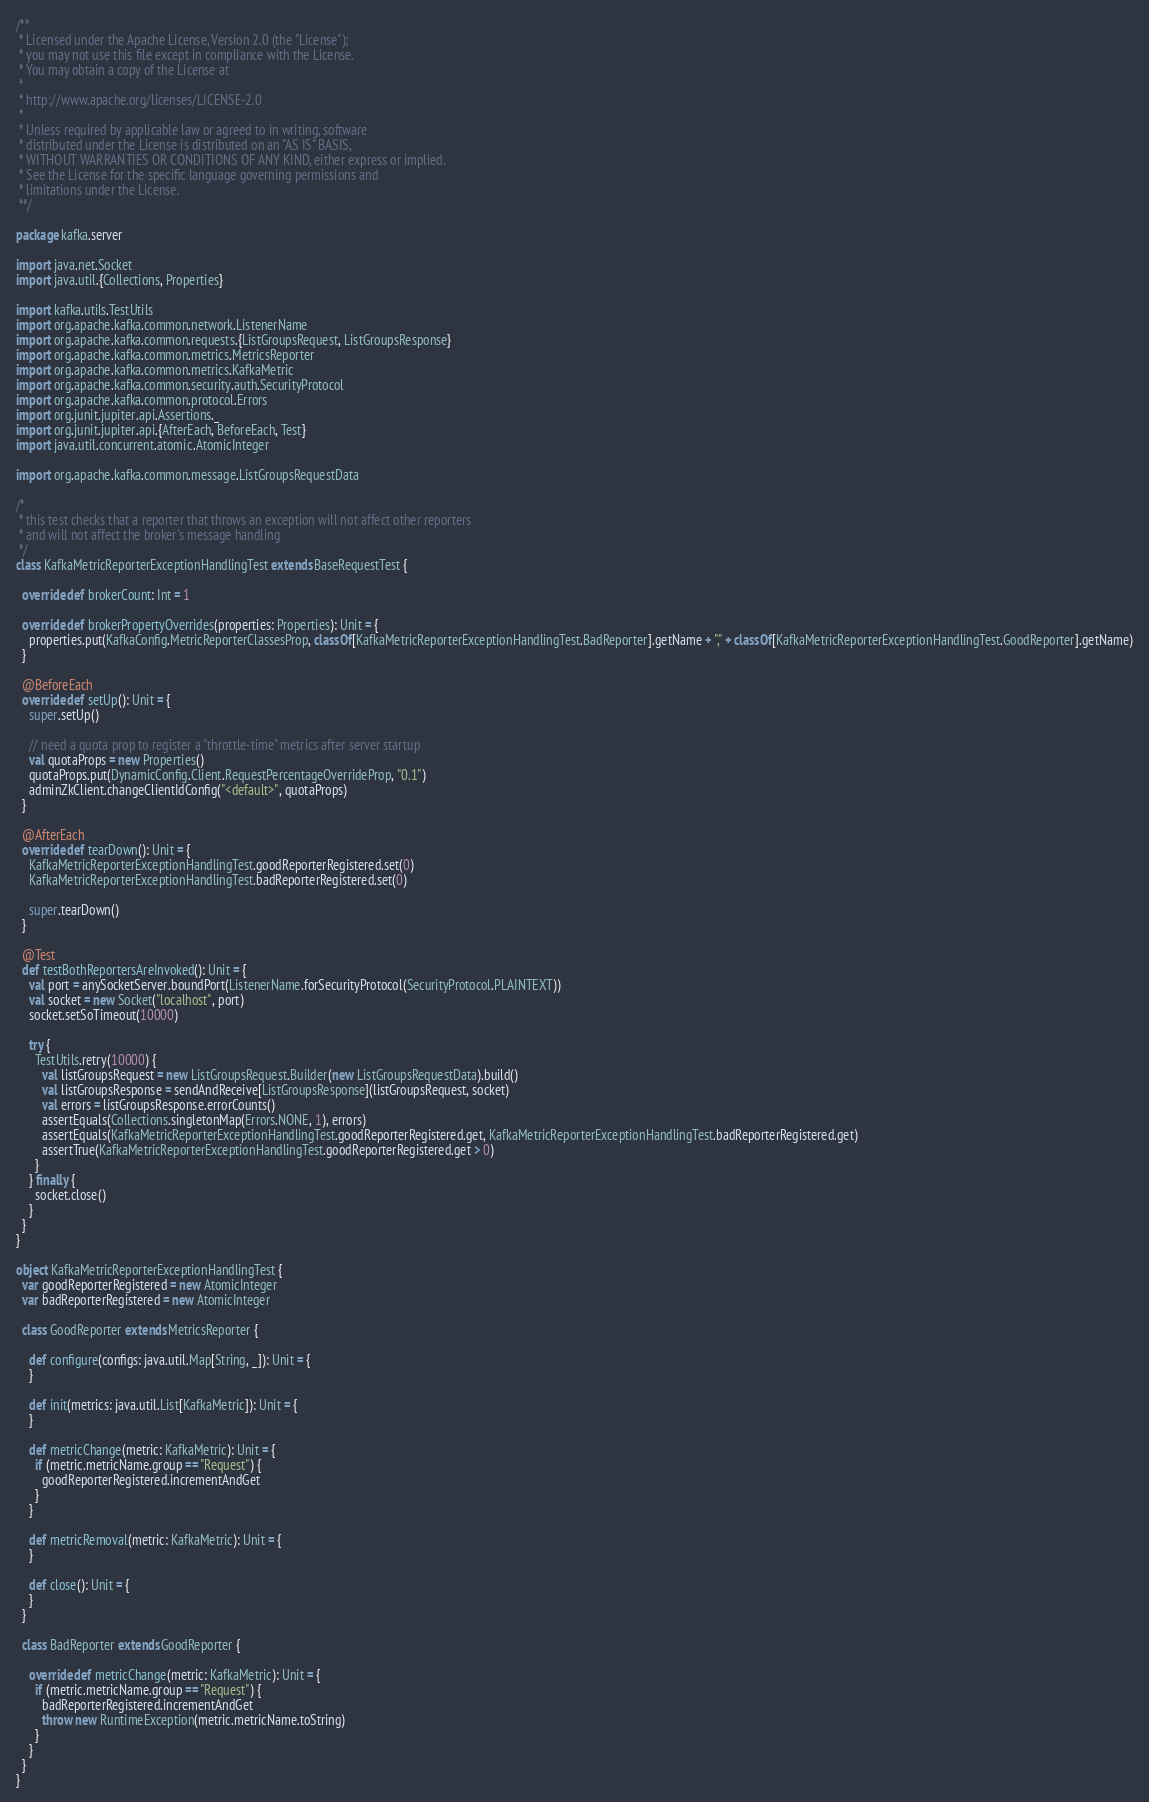Convert code to text. <code><loc_0><loc_0><loc_500><loc_500><_Scala_>/**
 * Licensed under the Apache License, Version 2.0 (the "License");
 * you may not use this file except in compliance with the License.
 * You may obtain a copy of the License at
 *
 * http://www.apache.org/licenses/LICENSE-2.0
 *
 * Unless required by applicable law or agreed to in writing, software
 * distributed under the License is distributed on an "AS IS" BASIS,
 * WITHOUT WARRANTIES OR CONDITIONS OF ANY KIND, either express or implied.
 * See the License for the specific language governing permissions and
 * limitations under the License.
 **/

package kafka.server

import java.net.Socket
import java.util.{Collections, Properties}

import kafka.utils.TestUtils
import org.apache.kafka.common.network.ListenerName
import org.apache.kafka.common.requests.{ListGroupsRequest, ListGroupsResponse}
import org.apache.kafka.common.metrics.MetricsReporter
import org.apache.kafka.common.metrics.KafkaMetric
import org.apache.kafka.common.security.auth.SecurityProtocol
import org.apache.kafka.common.protocol.Errors
import org.junit.jupiter.api.Assertions._
import org.junit.jupiter.api.{AfterEach, BeforeEach, Test}
import java.util.concurrent.atomic.AtomicInteger

import org.apache.kafka.common.message.ListGroupsRequestData

/*
 * this test checks that a reporter that throws an exception will not affect other reporters
 * and will not affect the broker's message handling
 */
class KafkaMetricReporterExceptionHandlingTest extends BaseRequestTest {

  override def brokerCount: Int = 1

  override def brokerPropertyOverrides(properties: Properties): Unit = {
    properties.put(KafkaConfig.MetricReporterClassesProp, classOf[KafkaMetricReporterExceptionHandlingTest.BadReporter].getName + "," + classOf[KafkaMetricReporterExceptionHandlingTest.GoodReporter].getName)
  }

  @BeforeEach
  override def setUp(): Unit = {
    super.setUp()

    // need a quota prop to register a "throttle-time" metrics after server startup
    val quotaProps = new Properties()
    quotaProps.put(DynamicConfig.Client.RequestPercentageOverrideProp, "0.1")
    adminZkClient.changeClientIdConfig("<default>", quotaProps)
  }

  @AfterEach
  override def tearDown(): Unit = {
    KafkaMetricReporterExceptionHandlingTest.goodReporterRegistered.set(0)
    KafkaMetricReporterExceptionHandlingTest.badReporterRegistered.set(0)
    
    super.tearDown()
  }

  @Test
  def testBothReportersAreInvoked(): Unit = {
    val port = anySocketServer.boundPort(ListenerName.forSecurityProtocol(SecurityProtocol.PLAINTEXT))
    val socket = new Socket("localhost", port)
    socket.setSoTimeout(10000)

    try {
      TestUtils.retry(10000) {
        val listGroupsRequest = new ListGroupsRequest.Builder(new ListGroupsRequestData).build()
        val listGroupsResponse = sendAndReceive[ListGroupsResponse](listGroupsRequest, socket)
        val errors = listGroupsResponse.errorCounts()
        assertEquals(Collections.singletonMap(Errors.NONE, 1), errors)
        assertEquals(KafkaMetricReporterExceptionHandlingTest.goodReporterRegistered.get, KafkaMetricReporterExceptionHandlingTest.badReporterRegistered.get)
        assertTrue(KafkaMetricReporterExceptionHandlingTest.goodReporterRegistered.get > 0)
      }
    } finally {
      socket.close()
    }
  }
}

object KafkaMetricReporterExceptionHandlingTest {
  var goodReporterRegistered = new AtomicInteger
  var badReporterRegistered = new AtomicInteger

  class GoodReporter extends MetricsReporter {

    def configure(configs: java.util.Map[String, _]): Unit = {
    }

    def init(metrics: java.util.List[KafkaMetric]): Unit = {
    }

    def metricChange(metric: KafkaMetric): Unit = {
      if (metric.metricName.group == "Request") {
        goodReporterRegistered.incrementAndGet
      }
    }

    def metricRemoval(metric: KafkaMetric): Unit = {
    }

    def close(): Unit = {
    }
  }

  class BadReporter extends GoodReporter {

    override def metricChange(metric: KafkaMetric): Unit = {
      if (metric.metricName.group == "Request") {
        badReporterRegistered.incrementAndGet
        throw new RuntimeException(metric.metricName.toString)
      }
    }
  }
}
</code> 